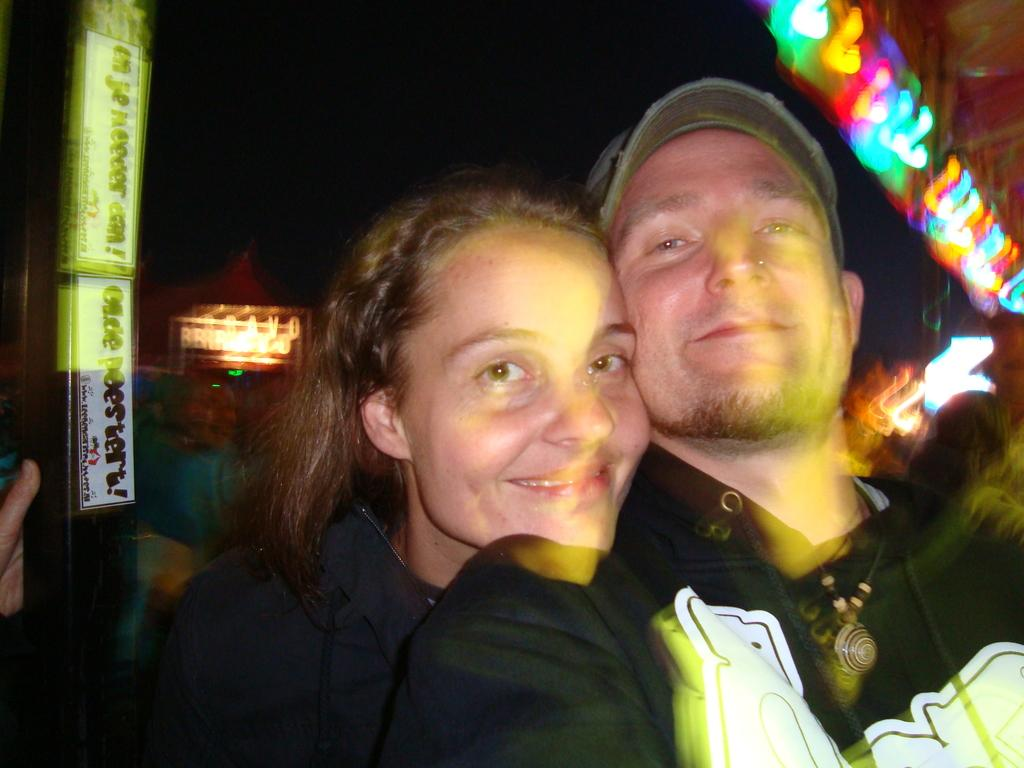How many people are in the image? There are two people in the image. What expressions do the people have? Both people are smiling. What direction are the people looking? The people are looking forward. What can be seen in the background of the image? There are lights and a board in the background of the image. Reasoning: Let'g: Let's think step by step in order to produce the conversation. We start by identifying the number of people in the image, which is two. Then, we describe their expressions and the direction they are looking. Next, we mention the background elements, which are lights and a board. Each question is designed to elicit a specific detail about the image that is known from the provided facts. Absurd Question/Answer: What grade is the person in the image currently in? There is no information about the person's grade in the image. What type of coat is the person wearing in the image? There is no coat visible in the image. What type of road can be seen in the image? There is no road visible in the image. 